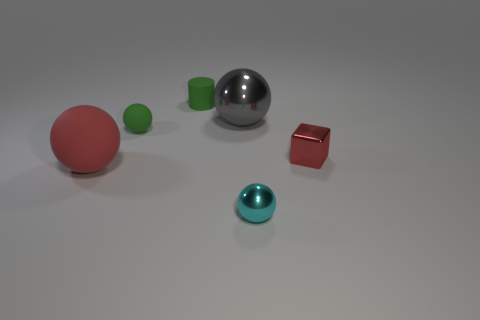Is there anything else of the same color as the big metal sphere?
Give a very brief answer. No. What number of objects are big gray balls or matte objects that are on the right side of the red sphere?
Offer a terse response. 3. What is the material of the red object that is the same shape as the cyan shiny thing?
Offer a very short reply. Rubber. There is a tiny object that is both in front of the matte cylinder and behind the red cube; what material is it made of?
Ensure brevity in your answer.  Rubber. What number of cyan objects have the same shape as the red matte thing?
Your answer should be very brief. 1. There is a metal sphere in front of the red object that is left of the cyan thing; what is its color?
Your answer should be very brief. Cyan. Are there the same number of cyan things that are on the right side of the tiny shiny sphere and metallic things?
Your response must be concise. No. Is there a red rubber cube that has the same size as the green ball?
Offer a very short reply. No. There is a shiny block; does it have the same size as the rubber sphere that is behind the small red shiny cube?
Make the answer very short. Yes. Are there the same number of big rubber things behind the tiny green rubber cylinder and large things in front of the cyan sphere?
Ensure brevity in your answer.  Yes. 